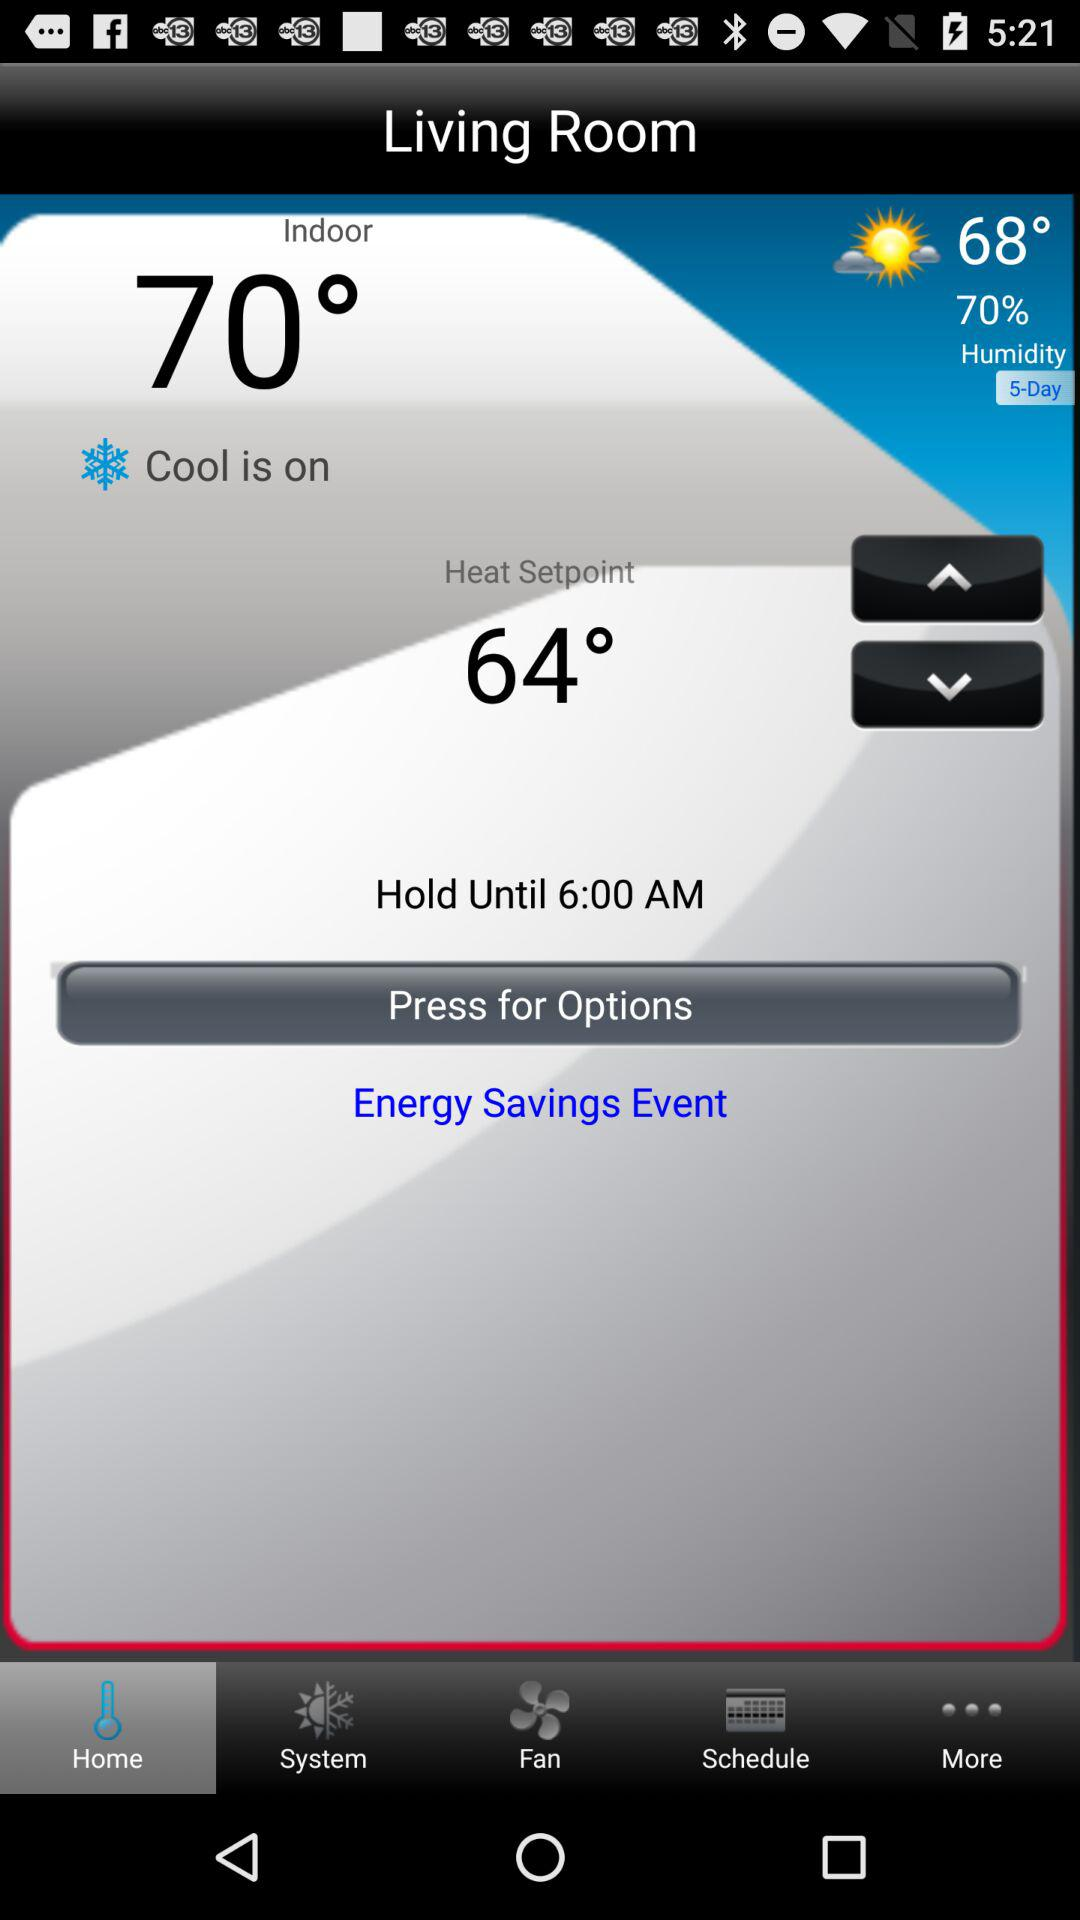What is the indoor temperature? The indoor temperature is 70 degrees. 